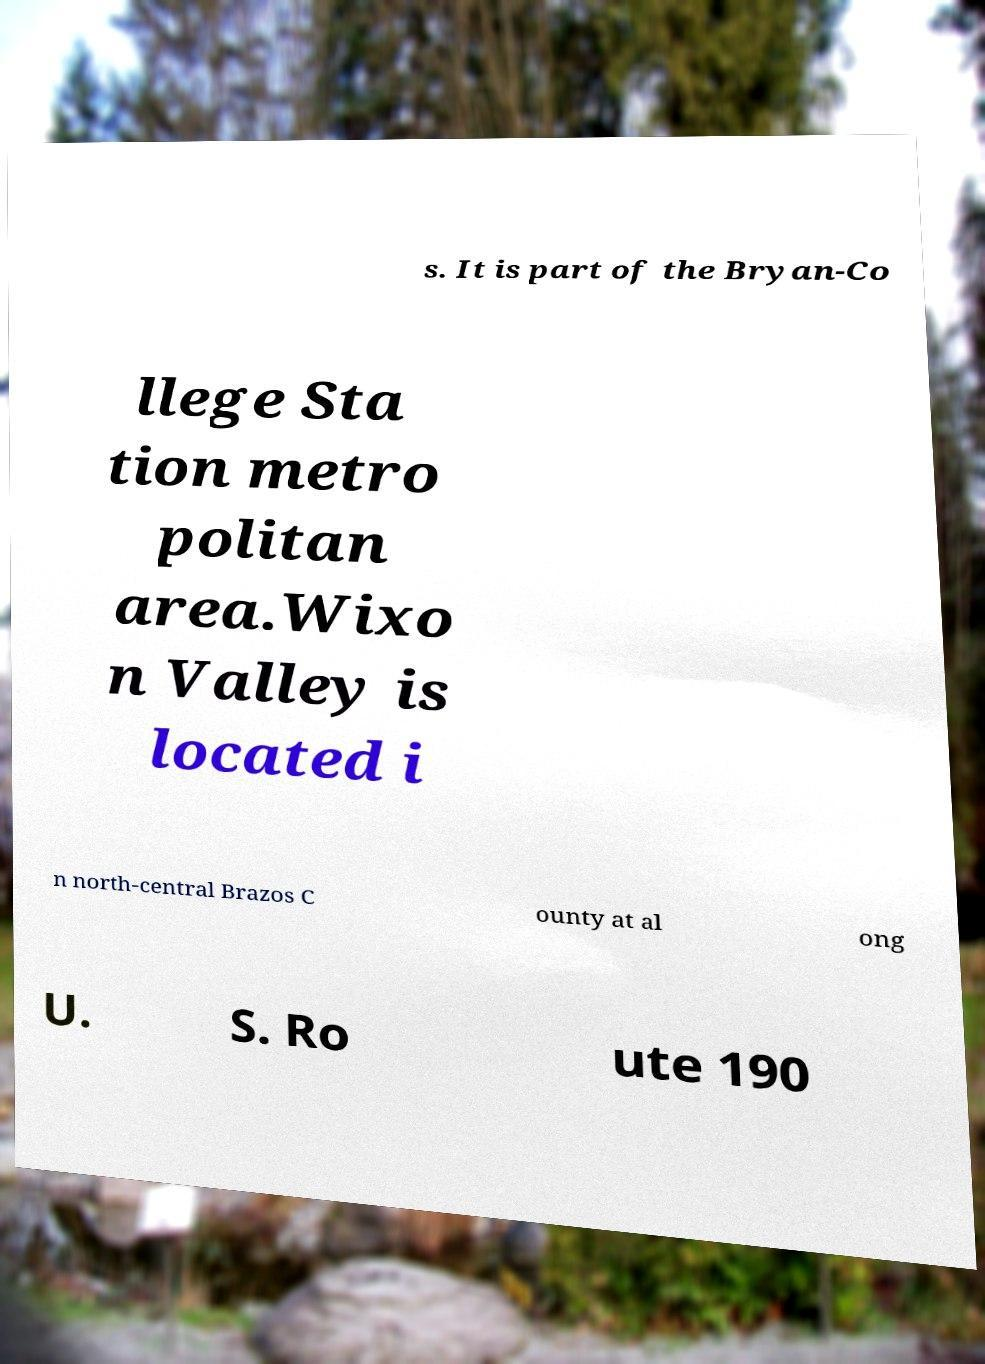Can you read and provide the text displayed in the image?This photo seems to have some interesting text. Can you extract and type it out for me? s. It is part of the Bryan-Co llege Sta tion metro politan area.Wixo n Valley is located i n north-central Brazos C ounty at al ong U. S. Ro ute 190 